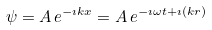<formula> <loc_0><loc_0><loc_500><loc_500>\psi = A \, e ^ { - \imath k x } = A \, e ^ { - \imath \omega t + \imath ( k r ) }</formula> 